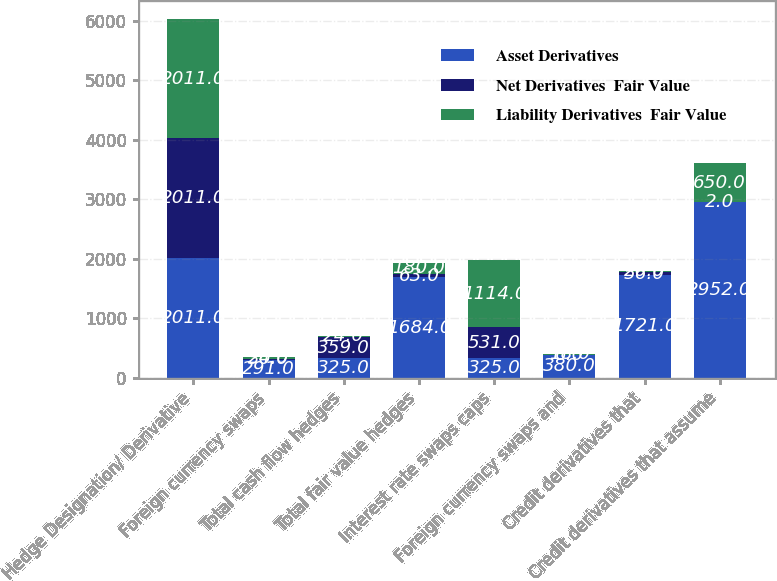Convert chart to OTSL. <chart><loc_0><loc_0><loc_500><loc_500><stacked_bar_chart><ecel><fcel>Hedge Designation/ Derivative<fcel>Foreign currency swaps<fcel>Total cash flow hedges<fcel>Total fair value hedges<fcel>Interest rate swaps caps<fcel>Foreign currency swaps and<fcel>Credit derivatives that<fcel>Credit derivatives that assume<nl><fcel>Asset Derivatives<fcel>2011<fcel>291<fcel>325<fcel>1684<fcel>325<fcel>380<fcel>1721<fcel>2952<nl><fcel>Net Derivatives  Fair Value<fcel>2011<fcel>30<fcel>359<fcel>63<fcel>531<fcel>6<fcel>56<fcel>2<nl><fcel>Liability Derivatives  Fair Value<fcel>2011<fcel>24<fcel>24<fcel>180<fcel>1114<fcel>18<fcel>20<fcel>650<nl></chart> 